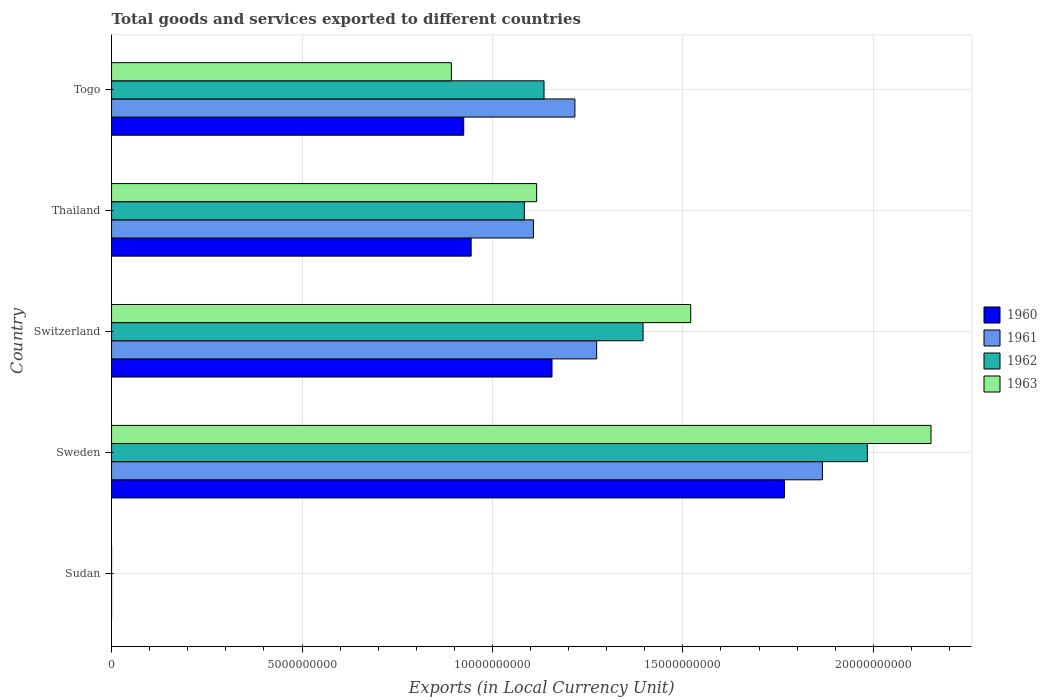Are the number of bars on each tick of the Y-axis equal?
Your response must be concise. Yes. How many bars are there on the 2nd tick from the bottom?
Provide a short and direct response. 4. What is the label of the 1st group of bars from the top?
Ensure brevity in your answer.  Togo. In how many cases, is the number of bars for a given country not equal to the number of legend labels?
Provide a succinct answer. 0. What is the Amount of goods and services exports in 1963 in Thailand?
Provide a short and direct response. 1.12e+1. Across all countries, what is the maximum Amount of goods and services exports in 1960?
Your response must be concise. 1.77e+1. Across all countries, what is the minimum Amount of goods and services exports in 1961?
Offer a terse response. 5.67e+04. In which country was the Amount of goods and services exports in 1960 minimum?
Your response must be concise. Sudan. What is the total Amount of goods and services exports in 1962 in the graph?
Keep it short and to the point. 5.60e+1. What is the difference between the Amount of goods and services exports in 1961 in Sweden and that in Thailand?
Your answer should be very brief. 7.59e+09. What is the difference between the Amount of goods and services exports in 1961 in Sudan and the Amount of goods and services exports in 1962 in Thailand?
Your response must be concise. -1.08e+1. What is the average Amount of goods and services exports in 1960 per country?
Make the answer very short. 9.58e+09. What is the difference between the Amount of goods and services exports in 1962 and Amount of goods and services exports in 1963 in Switzerland?
Keep it short and to the point. -1.25e+09. What is the ratio of the Amount of goods and services exports in 1960 in Sudan to that in Thailand?
Your answer should be compact. 6.0480881262578115e-6. Is the difference between the Amount of goods and services exports in 1962 in Switzerland and Togo greater than the difference between the Amount of goods and services exports in 1963 in Switzerland and Togo?
Provide a succinct answer. No. What is the difference between the highest and the second highest Amount of goods and services exports in 1963?
Your response must be concise. 6.31e+09. What is the difference between the highest and the lowest Amount of goods and services exports in 1962?
Keep it short and to the point. 1.98e+1. Is the sum of the Amount of goods and services exports in 1962 in Sweden and Togo greater than the maximum Amount of goods and services exports in 1961 across all countries?
Offer a very short reply. Yes. What does the 1st bar from the bottom in Sudan represents?
Make the answer very short. 1960. Is it the case that in every country, the sum of the Amount of goods and services exports in 1963 and Amount of goods and services exports in 1962 is greater than the Amount of goods and services exports in 1961?
Offer a very short reply. Yes. What is the difference between two consecutive major ticks on the X-axis?
Provide a succinct answer. 5.00e+09. Does the graph contain grids?
Provide a short and direct response. Yes. What is the title of the graph?
Offer a terse response. Total goods and services exported to different countries. Does "2001" appear as one of the legend labels in the graph?
Give a very brief answer. No. What is the label or title of the X-axis?
Provide a succinct answer. Exports (in Local Currency Unit). What is the label or title of the Y-axis?
Provide a short and direct response. Country. What is the Exports (in Local Currency Unit) in 1960 in Sudan?
Keep it short and to the point. 5.71e+04. What is the Exports (in Local Currency Unit) in 1961 in Sudan?
Provide a succinct answer. 5.67e+04. What is the Exports (in Local Currency Unit) in 1962 in Sudan?
Keep it short and to the point. 6.76e+04. What is the Exports (in Local Currency Unit) of 1963 in Sudan?
Ensure brevity in your answer.  7.86e+04. What is the Exports (in Local Currency Unit) of 1960 in Sweden?
Offer a terse response. 1.77e+1. What is the Exports (in Local Currency Unit) of 1961 in Sweden?
Provide a short and direct response. 1.87e+1. What is the Exports (in Local Currency Unit) of 1962 in Sweden?
Keep it short and to the point. 1.98e+1. What is the Exports (in Local Currency Unit) of 1963 in Sweden?
Make the answer very short. 2.15e+1. What is the Exports (in Local Currency Unit) in 1960 in Switzerland?
Your answer should be very brief. 1.16e+1. What is the Exports (in Local Currency Unit) in 1961 in Switzerland?
Your answer should be very brief. 1.27e+1. What is the Exports (in Local Currency Unit) of 1962 in Switzerland?
Offer a terse response. 1.40e+1. What is the Exports (in Local Currency Unit) in 1963 in Switzerland?
Make the answer very short. 1.52e+1. What is the Exports (in Local Currency Unit) of 1960 in Thailand?
Ensure brevity in your answer.  9.44e+09. What is the Exports (in Local Currency Unit) of 1961 in Thailand?
Keep it short and to the point. 1.11e+1. What is the Exports (in Local Currency Unit) in 1962 in Thailand?
Give a very brief answer. 1.08e+1. What is the Exports (in Local Currency Unit) in 1963 in Thailand?
Your answer should be very brief. 1.12e+1. What is the Exports (in Local Currency Unit) of 1960 in Togo?
Keep it short and to the point. 9.25e+09. What is the Exports (in Local Currency Unit) of 1961 in Togo?
Give a very brief answer. 1.22e+1. What is the Exports (in Local Currency Unit) in 1962 in Togo?
Keep it short and to the point. 1.14e+1. What is the Exports (in Local Currency Unit) in 1963 in Togo?
Give a very brief answer. 8.92e+09. Across all countries, what is the maximum Exports (in Local Currency Unit) of 1960?
Offer a very short reply. 1.77e+1. Across all countries, what is the maximum Exports (in Local Currency Unit) in 1961?
Make the answer very short. 1.87e+1. Across all countries, what is the maximum Exports (in Local Currency Unit) of 1962?
Ensure brevity in your answer.  1.98e+1. Across all countries, what is the maximum Exports (in Local Currency Unit) of 1963?
Offer a terse response. 2.15e+1. Across all countries, what is the minimum Exports (in Local Currency Unit) of 1960?
Ensure brevity in your answer.  5.71e+04. Across all countries, what is the minimum Exports (in Local Currency Unit) of 1961?
Your answer should be very brief. 5.67e+04. Across all countries, what is the minimum Exports (in Local Currency Unit) in 1962?
Your response must be concise. 6.76e+04. Across all countries, what is the minimum Exports (in Local Currency Unit) in 1963?
Ensure brevity in your answer.  7.86e+04. What is the total Exports (in Local Currency Unit) of 1960 in the graph?
Provide a short and direct response. 4.79e+1. What is the total Exports (in Local Currency Unit) of 1961 in the graph?
Provide a short and direct response. 5.46e+1. What is the total Exports (in Local Currency Unit) of 1962 in the graph?
Keep it short and to the point. 5.60e+1. What is the total Exports (in Local Currency Unit) of 1963 in the graph?
Make the answer very short. 5.68e+1. What is the difference between the Exports (in Local Currency Unit) in 1960 in Sudan and that in Sweden?
Your answer should be compact. -1.77e+1. What is the difference between the Exports (in Local Currency Unit) in 1961 in Sudan and that in Sweden?
Your answer should be very brief. -1.87e+1. What is the difference between the Exports (in Local Currency Unit) of 1962 in Sudan and that in Sweden?
Provide a short and direct response. -1.98e+1. What is the difference between the Exports (in Local Currency Unit) of 1963 in Sudan and that in Sweden?
Your answer should be compact. -2.15e+1. What is the difference between the Exports (in Local Currency Unit) in 1960 in Sudan and that in Switzerland?
Offer a very short reply. -1.16e+1. What is the difference between the Exports (in Local Currency Unit) of 1961 in Sudan and that in Switzerland?
Offer a terse response. -1.27e+1. What is the difference between the Exports (in Local Currency Unit) in 1962 in Sudan and that in Switzerland?
Offer a terse response. -1.40e+1. What is the difference between the Exports (in Local Currency Unit) in 1963 in Sudan and that in Switzerland?
Give a very brief answer. -1.52e+1. What is the difference between the Exports (in Local Currency Unit) in 1960 in Sudan and that in Thailand?
Keep it short and to the point. -9.44e+09. What is the difference between the Exports (in Local Currency Unit) in 1961 in Sudan and that in Thailand?
Offer a very short reply. -1.11e+1. What is the difference between the Exports (in Local Currency Unit) of 1962 in Sudan and that in Thailand?
Ensure brevity in your answer.  -1.08e+1. What is the difference between the Exports (in Local Currency Unit) of 1963 in Sudan and that in Thailand?
Offer a very short reply. -1.12e+1. What is the difference between the Exports (in Local Currency Unit) in 1960 in Sudan and that in Togo?
Offer a very short reply. -9.25e+09. What is the difference between the Exports (in Local Currency Unit) of 1961 in Sudan and that in Togo?
Give a very brief answer. -1.22e+1. What is the difference between the Exports (in Local Currency Unit) of 1962 in Sudan and that in Togo?
Offer a terse response. -1.14e+1. What is the difference between the Exports (in Local Currency Unit) of 1963 in Sudan and that in Togo?
Keep it short and to the point. -8.92e+09. What is the difference between the Exports (in Local Currency Unit) of 1960 in Sweden and that in Switzerland?
Make the answer very short. 6.10e+09. What is the difference between the Exports (in Local Currency Unit) in 1961 in Sweden and that in Switzerland?
Keep it short and to the point. 5.93e+09. What is the difference between the Exports (in Local Currency Unit) of 1962 in Sweden and that in Switzerland?
Provide a succinct answer. 5.89e+09. What is the difference between the Exports (in Local Currency Unit) in 1963 in Sweden and that in Switzerland?
Offer a terse response. 6.31e+09. What is the difference between the Exports (in Local Currency Unit) in 1960 in Sweden and that in Thailand?
Ensure brevity in your answer.  8.23e+09. What is the difference between the Exports (in Local Currency Unit) in 1961 in Sweden and that in Thailand?
Provide a succinct answer. 7.59e+09. What is the difference between the Exports (in Local Currency Unit) in 1962 in Sweden and that in Thailand?
Make the answer very short. 9.01e+09. What is the difference between the Exports (in Local Currency Unit) of 1963 in Sweden and that in Thailand?
Your answer should be very brief. 1.04e+1. What is the difference between the Exports (in Local Currency Unit) in 1960 in Sweden and that in Togo?
Provide a succinct answer. 8.42e+09. What is the difference between the Exports (in Local Currency Unit) of 1961 in Sweden and that in Togo?
Give a very brief answer. 6.50e+09. What is the difference between the Exports (in Local Currency Unit) of 1962 in Sweden and that in Togo?
Provide a short and direct response. 8.49e+09. What is the difference between the Exports (in Local Currency Unit) of 1963 in Sweden and that in Togo?
Offer a terse response. 1.26e+1. What is the difference between the Exports (in Local Currency Unit) of 1960 in Switzerland and that in Thailand?
Your response must be concise. 2.12e+09. What is the difference between the Exports (in Local Currency Unit) of 1961 in Switzerland and that in Thailand?
Provide a succinct answer. 1.66e+09. What is the difference between the Exports (in Local Currency Unit) in 1962 in Switzerland and that in Thailand?
Offer a very short reply. 3.12e+09. What is the difference between the Exports (in Local Currency Unit) of 1963 in Switzerland and that in Thailand?
Your answer should be very brief. 4.05e+09. What is the difference between the Exports (in Local Currency Unit) in 1960 in Switzerland and that in Togo?
Your response must be concise. 2.32e+09. What is the difference between the Exports (in Local Currency Unit) in 1961 in Switzerland and that in Togo?
Provide a succinct answer. 5.70e+08. What is the difference between the Exports (in Local Currency Unit) of 1962 in Switzerland and that in Togo?
Provide a short and direct response. 2.60e+09. What is the difference between the Exports (in Local Currency Unit) of 1963 in Switzerland and that in Togo?
Make the answer very short. 6.28e+09. What is the difference between the Exports (in Local Currency Unit) of 1960 in Thailand and that in Togo?
Provide a succinct answer. 1.95e+08. What is the difference between the Exports (in Local Currency Unit) in 1961 in Thailand and that in Togo?
Make the answer very short. -1.09e+09. What is the difference between the Exports (in Local Currency Unit) in 1962 in Thailand and that in Togo?
Offer a terse response. -5.17e+08. What is the difference between the Exports (in Local Currency Unit) of 1963 in Thailand and that in Togo?
Provide a succinct answer. 2.24e+09. What is the difference between the Exports (in Local Currency Unit) in 1960 in Sudan and the Exports (in Local Currency Unit) in 1961 in Sweden?
Ensure brevity in your answer.  -1.87e+1. What is the difference between the Exports (in Local Currency Unit) in 1960 in Sudan and the Exports (in Local Currency Unit) in 1962 in Sweden?
Offer a very short reply. -1.98e+1. What is the difference between the Exports (in Local Currency Unit) in 1960 in Sudan and the Exports (in Local Currency Unit) in 1963 in Sweden?
Give a very brief answer. -2.15e+1. What is the difference between the Exports (in Local Currency Unit) of 1961 in Sudan and the Exports (in Local Currency Unit) of 1962 in Sweden?
Your response must be concise. -1.98e+1. What is the difference between the Exports (in Local Currency Unit) of 1961 in Sudan and the Exports (in Local Currency Unit) of 1963 in Sweden?
Provide a succinct answer. -2.15e+1. What is the difference between the Exports (in Local Currency Unit) in 1962 in Sudan and the Exports (in Local Currency Unit) in 1963 in Sweden?
Your answer should be very brief. -2.15e+1. What is the difference between the Exports (in Local Currency Unit) of 1960 in Sudan and the Exports (in Local Currency Unit) of 1961 in Switzerland?
Provide a short and direct response. -1.27e+1. What is the difference between the Exports (in Local Currency Unit) in 1960 in Sudan and the Exports (in Local Currency Unit) in 1962 in Switzerland?
Your answer should be very brief. -1.40e+1. What is the difference between the Exports (in Local Currency Unit) in 1960 in Sudan and the Exports (in Local Currency Unit) in 1963 in Switzerland?
Provide a succinct answer. -1.52e+1. What is the difference between the Exports (in Local Currency Unit) of 1961 in Sudan and the Exports (in Local Currency Unit) of 1962 in Switzerland?
Provide a succinct answer. -1.40e+1. What is the difference between the Exports (in Local Currency Unit) of 1961 in Sudan and the Exports (in Local Currency Unit) of 1963 in Switzerland?
Your answer should be compact. -1.52e+1. What is the difference between the Exports (in Local Currency Unit) in 1962 in Sudan and the Exports (in Local Currency Unit) in 1963 in Switzerland?
Keep it short and to the point. -1.52e+1. What is the difference between the Exports (in Local Currency Unit) of 1960 in Sudan and the Exports (in Local Currency Unit) of 1961 in Thailand?
Provide a short and direct response. -1.11e+1. What is the difference between the Exports (in Local Currency Unit) in 1960 in Sudan and the Exports (in Local Currency Unit) in 1962 in Thailand?
Your answer should be very brief. -1.08e+1. What is the difference between the Exports (in Local Currency Unit) of 1960 in Sudan and the Exports (in Local Currency Unit) of 1963 in Thailand?
Offer a very short reply. -1.12e+1. What is the difference between the Exports (in Local Currency Unit) in 1961 in Sudan and the Exports (in Local Currency Unit) in 1962 in Thailand?
Make the answer very short. -1.08e+1. What is the difference between the Exports (in Local Currency Unit) in 1961 in Sudan and the Exports (in Local Currency Unit) in 1963 in Thailand?
Your response must be concise. -1.12e+1. What is the difference between the Exports (in Local Currency Unit) in 1962 in Sudan and the Exports (in Local Currency Unit) in 1963 in Thailand?
Provide a succinct answer. -1.12e+1. What is the difference between the Exports (in Local Currency Unit) of 1960 in Sudan and the Exports (in Local Currency Unit) of 1961 in Togo?
Provide a succinct answer. -1.22e+1. What is the difference between the Exports (in Local Currency Unit) of 1960 in Sudan and the Exports (in Local Currency Unit) of 1962 in Togo?
Provide a succinct answer. -1.14e+1. What is the difference between the Exports (in Local Currency Unit) of 1960 in Sudan and the Exports (in Local Currency Unit) of 1963 in Togo?
Your response must be concise. -8.92e+09. What is the difference between the Exports (in Local Currency Unit) in 1961 in Sudan and the Exports (in Local Currency Unit) in 1962 in Togo?
Your answer should be very brief. -1.14e+1. What is the difference between the Exports (in Local Currency Unit) in 1961 in Sudan and the Exports (in Local Currency Unit) in 1963 in Togo?
Your response must be concise. -8.92e+09. What is the difference between the Exports (in Local Currency Unit) in 1962 in Sudan and the Exports (in Local Currency Unit) in 1963 in Togo?
Offer a terse response. -8.92e+09. What is the difference between the Exports (in Local Currency Unit) in 1960 in Sweden and the Exports (in Local Currency Unit) in 1961 in Switzerland?
Offer a terse response. 4.93e+09. What is the difference between the Exports (in Local Currency Unit) of 1960 in Sweden and the Exports (in Local Currency Unit) of 1962 in Switzerland?
Your response must be concise. 3.71e+09. What is the difference between the Exports (in Local Currency Unit) in 1960 in Sweden and the Exports (in Local Currency Unit) in 1963 in Switzerland?
Make the answer very short. 2.46e+09. What is the difference between the Exports (in Local Currency Unit) in 1961 in Sweden and the Exports (in Local Currency Unit) in 1962 in Switzerland?
Your answer should be very brief. 4.71e+09. What is the difference between the Exports (in Local Currency Unit) in 1961 in Sweden and the Exports (in Local Currency Unit) in 1963 in Switzerland?
Ensure brevity in your answer.  3.46e+09. What is the difference between the Exports (in Local Currency Unit) of 1962 in Sweden and the Exports (in Local Currency Unit) of 1963 in Switzerland?
Keep it short and to the point. 4.64e+09. What is the difference between the Exports (in Local Currency Unit) in 1960 in Sweden and the Exports (in Local Currency Unit) in 1961 in Thailand?
Make the answer very short. 6.59e+09. What is the difference between the Exports (in Local Currency Unit) of 1960 in Sweden and the Exports (in Local Currency Unit) of 1962 in Thailand?
Give a very brief answer. 6.83e+09. What is the difference between the Exports (in Local Currency Unit) of 1960 in Sweden and the Exports (in Local Currency Unit) of 1963 in Thailand?
Provide a short and direct response. 6.51e+09. What is the difference between the Exports (in Local Currency Unit) in 1961 in Sweden and the Exports (in Local Currency Unit) in 1962 in Thailand?
Make the answer very short. 7.83e+09. What is the difference between the Exports (in Local Currency Unit) of 1961 in Sweden and the Exports (in Local Currency Unit) of 1963 in Thailand?
Make the answer very short. 7.50e+09. What is the difference between the Exports (in Local Currency Unit) in 1962 in Sweden and the Exports (in Local Currency Unit) in 1963 in Thailand?
Ensure brevity in your answer.  8.68e+09. What is the difference between the Exports (in Local Currency Unit) in 1960 in Sweden and the Exports (in Local Currency Unit) in 1961 in Togo?
Make the answer very short. 5.50e+09. What is the difference between the Exports (in Local Currency Unit) in 1960 in Sweden and the Exports (in Local Currency Unit) in 1962 in Togo?
Your response must be concise. 6.31e+09. What is the difference between the Exports (in Local Currency Unit) in 1960 in Sweden and the Exports (in Local Currency Unit) in 1963 in Togo?
Give a very brief answer. 8.75e+09. What is the difference between the Exports (in Local Currency Unit) of 1961 in Sweden and the Exports (in Local Currency Unit) of 1962 in Togo?
Your answer should be compact. 7.31e+09. What is the difference between the Exports (in Local Currency Unit) in 1961 in Sweden and the Exports (in Local Currency Unit) in 1963 in Togo?
Make the answer very short. 9.74e+09. What is the difference between the Exports (in Local Currency Unit) of 1962 in Sweden and the Exports (in Local Currency Unit) of 1963 in Togo?
Provide a succinct answer. 1.09e+1. What is the difference between the Exports (in Local Currency Unit) of 1960 in Switzerland and the Exports (in Local Currency Unit) of 1961 in Thailand?
Provide a short and direct response. 4.88e+08. What is the difference between the Exports (in Local Currency Unit) of 1960 in Switzerland and the Exports (in Local Currency Unit) of 1962 in Thailand?
Your answer should be very brief. 7.26e+08. What is the difference between the Exports (in Local Currency Unit) in 1960 in Switzerland and the Exports (in Local Currency Unit) in 1963 in Thailand?
Your answer should be compact. 4.03e+08. What is the difference between the Exports (in Local Currency Unit) in 1961 in Switzerland and the Exports (in Local Currency Unit) in 1962 in Thailand?
Your answer should be very brief. 1.90e+09. What is the difference between the Exports (in Local Currency Unit) in 1961 in Switzerland and the Exports (in Local Currency Unit) in 1963 in Thailand?
Offer a terse response. 1.58e+09. What is the difference between the Exports (in Local Currency Unit) of 1962 in Switzerland and the Exports (in Local Currency Unit) of 1963 in Thailand?
Provide a succinct answer. 2.79e+09. What is the difference between the Exports (in Local Currency Unit) in 1960 in Switzerland and the Exports (in Local Currency Unit) in 1961 in Togo?
Provide a succinct answer. -6.01e+08. What is the difference between the Exports (in Local Currency Unit) of 1960 in Switzerland and the Exports (in Local Currency Unit) of 1962 in Togo?
Ensure brevity in your answer.  2.10e+08. What is the difference between the Exports (in Local Currency Unit) of 1960 in Switzerland and the Exports (in Local Currency Unit) of 1963 in Togo?
Your answer should be very brief. 2.64e+09. What is the difference between the Exports (in Local Currency Unit) of 1961 in Switzerland and the Exports (in Local Currency Unit) of 1962 in Togo?
Offer a terse response. 1.38e+09. What is the difference between the Exports (in Local Currency Unit) of 1961 in Switzerland and the Exports (in Local Currency Unit) of 1963 in Togo?
Ensure brevity in your answer.  3.81e+09. What is the difference between the Exports (in Local Currency Unit) of 1962 in Switzerland and the Exports (in Local Currency Unit) of 1963 in Togo?
Keep it short and to the point. 5.03e+09. What is the difference between the Exports (in Local Currency Unit) of 1960 in Thailand and the Exports (in Local Currency Unit) of 1961 in Togo?
Your answer should be compact. -2.72e+09. What is the difference between the Exports (in Local Currency Unit) in 1960 in Thailand and the Exports (in Local Currency Unit) in 1962 in Togo?
Ensure brevity in your answer.  -1.91e+09. What is the difference between the Exports (in Local Currency Unit) of 1960 in Thailand and the Exports (in Local Currency Unit) of 1963 in Togo?
Offer a terse response. 5.19e+08. What is the difference between the Exports (in Local Currency Unit) in 1961 in Thailand and the Exports (in Local Currency Unit) in 1962 in Togo?
Make the answer very short. -2.79e+08. What is the difference between the Exports (in Local Currency Unit) in 1961 in Thailand and the Exports (in Local Currency Unit) in 1963 in Togo?
Provide a succinct answer. 2.15e+09. What is the difference between the Exports (in Local Currency Unit) of 1962 in Thailand and the Exports (in Local Currency Unit) of 1963 in Togo?
Offer a very short reply. 1.92e+09. What is the average Exports (in Local Currency Unit) of 1960 per country?
Offer a very short reply. 9.58e+09. What is the average Exports (in Local Currency Unit) in 1961 per country?
Your answer should be very brief. 1.09e+1. What is the average Exports (in Local Currency Unit) of 1962 per country?
Your answer should be compact. 1.12e+1. What is the average Exports (in Local Currency Unit) in 1963 per country?
Give a very brief answer. 1.14e+1. What is the difference between the Exports (in Local Currency Unit) of 1960 and Exports (in Local Currency Unit) of 1961 in Sudan?
Your response must be concise. 400. What is the difference between the Exports (in Local Currency Unit) in 1960 and Exports (in Local Currency Unit) in 1962 in Sudan?
Make the answer very short. -1.05e+04. What is the difference between the Exports (in Local Currency Unit) in 1960 and Exports (in Local Currency Unit) in 1963 in Sudan?
Provide a succinct answer. -2.15e+04. What is the difference between the Exports (in Local Currency Unit) in 1961 and Exports (in Local Currency Unit) in 1962 in Sudan?
Offer a very short reply. -1.09e+04. What is the difference between the Exports (in Local Currency Unit) in 1961 and Exports (in Local Currency Unit) in 1963 in Sudan?
Give a very brief answer. -2.19e+04. What is the difference between the Exports (in Local Currency Unit) of 1962 and Exports (in Local Currency Unit) of 1963 in Sudan?
Ensure brevity in your answer.  -1.10e+04. What is the difference between the Exports (in Local Currency Unit) in 1960 and Exports (in Local Currency Unit) in 1961 in Sweden?
Offer a terse response. -9.97e+08. What is the difference between the Exports (in Local Currency Unit) of 1960 and Exports (in Local Currency Unit) of 1962 in Sweden?
Your answer should be compact. -2.18e+09. What is the difference between the Exports (in Local Currency Unit) in 1960 and Exports (in Local Currency Unit) in 1963 in Sweden?
Provide a succinct answer. -3.85e+09. What is the difference between the Exports (in Local Currency Unit) of 1961 and Exports (in Local Currency Unit) of 1962 in Sweden?
Your response must be concise. -1.18e+09. What is the difference between the Exports (in Local Currency Unit) in 1961 and Exports (in Local Currency Unit) in 1963 in Sweden?
Your answer should be very brief. -2.85e+09. What is the difference between the Exports (in Local Currency Unit) in 1962 and Exports (in Local Currency Unit) in 1963 in Sweden?
Ensure brevity in your answer.  -1.67e+09. What is the difference between the Exports (in Local Currency Unit) of 1960 and Exports (in Local Currency Unit) of 1961 in Switzerland?
Give a very brief answer. -1.17e+09. What is the difference between the Exports (in Local Currency Unit) in 1960 and Exports (in Local Currency Unit) in 1962 in Switzerland?
Offer a very short reply. -2.39e+09. What is the difference between the Exports (in Local Currency Unit) in 1960 and Exports (in Local Currency Unit) in 1963 in Switzerland?
Offer a terse response. -3.64e+09. What is the difference between the Exports (in Local Currency Unit) of 1961 and Exports (in Local Currency Unit) of 1962 in Switzerland?
Your answer should be compact. -1.22e+09. What is the difference between the Exports (in Local Currency Unit) of 1961 and Exports (in Local Currency Unit) of 1963 in Switzerland?
Your answer should be very brief. -2.47e+09. What is the difference between the Exports (in Local Currency Unit) in 1962 and Exports (in Local Currency Unit) in 1963 in Switzerland?
Your answer should be very brief. -1.25e+09. What is the difference between the Exports (in Local Currency Unit) of 1960 and Exports (in Local Currency Unit) of 1961 in Thailand?
Your response must be concise. -1.64e+09. What is the difference between the Exports (in Local Currency Unit) of 1960 and Exports (in Local Currency Unit) of 1962 in Thailand?
Offer a very short reply. -1.40e+09. What is the difference between the Exports (in Local Currency Unit) in 1960 and Exports (in Local Currency Unit) in 1963 in Thailand?
Give a very brief answer. -1.72e+09. What is the difference between the Exports (in Local Currency Unit) of 1961 and Exports (in Local Currency Unit) of 1962 in Thailand?
Offer a terse response. 2.38e+08. What is the difference between the Exports (in Local Currency Unit) in 1961 and Exports (in Local Currency Unit) in 1963 in Thailand?
Provide a succinct answer. -8.50e+07. What is the difference between the Exports (in Local Currency Unit) in 1962 and Exports (in Local Currency Unit) in 1963 in Thailand?
Your response must be concise. -3.23e+08. What is the difference between the Exports (in Local Currency Unit) in 1960 and Exports (in Local Currency Unit) in 1961 in Togo?
Your response must be concise. -2.92e+09. What is the difference between the Exports (in Local Currency Unit) of 1960 and Exports (in Local Currency Unit) of 1962 in Togo?
Ensure brevity in your answer.  -2.11e+09. What is the difference between the Exports (in Local Currency Unit) in 1960 and Exports (in Local Currency Unit) in 1963 in Togo?
Give a very brief answer. 3.24e+08. What is the difference between the Exports (in Local Currency Unit) of 1961 and Exports (in Local Currency Unit) of 1962 in Togo?
Keep it short and to the point. 8.11e+08. What is the difference between the Exports (in Local Currency Unit) of 1961 and Exports (in Local Currency Unit) of 1963 in Togo?
Keep it short and to the point. 3.24e+09. What is the difference between the Exports (in Local Currency Unit) in 1962 and Exports (in Local Currency Unit) in 1963 in Togo?
Offer a terse response. 2.43e+09. What is the ratio of the Exports (in Local Currency Unit) in 1960 in Sudan to that in Sweden?
Offer a very short reply. 0. What is the ratio of the Exports (in Local Currency Unit) of 1961 in Sudan to that in Sweden?
Your answer should be compact. 0. What is the ratio of the Exports (in Local Currency Unit) in 1962 in Sudan to that in Sweden?
Your response must be concise. 0. What is the ratio of the Exports (in Local Currency Unit) of 1960 in Sudan to that in Switzerland?
Make the answer very short. 0. What is the ratio of the Exports (in Local Currency Unit) of 1963 in Sudan to that in Switzerland?
Ensure brevity in your answer.  0. What is the ratio of the Exports (in Local Currency Unit) in 1960 in Sudan to that in Thailand?
Offer a terse response. 0. What is the ratio of the Exports (in Local Currency Unit) in 1961 in Sudan to that in Thailand?
Ensure brevity in your answer.  0. What is the ratio of the Exports (in Local Currency Unit) of 1960 in Sudan to that in Togo?
Offer a terse response. 0. What is the ratio of the Exports (in Local Currency Unit) in 1961 in Sudan to that in Togo?
Offer a very short reply. 0. What is the ratio of the Exports (in Local Currency Unit) of 1962 in Sudan to that in Togo?
Offer a terse response. 0. What is the ratio of the Exports (in Local Currency Unit) in 1960 in Sweden to that in Switzerland?
Keep it short and to the point. 1.53. What is the ratio of the Exports (in Local Currency Unit) in 1961 in Sweden to that in Switzerland?
Your response must be concise. 1.47. What is the ratio of the Exports (in Local Currency Unit) in 1962 in Sweden to that in Switzerland?
Make the answer very short. 1.42. What is the ratio of the Exports (in Local Currency Unit) of 1963 in Sweden to that in Switzerland?
Your response must be concise. 1.41. What is the ratio of the Exports (in Local Currency Unit) of 1960 in Sweden to that in Thailand?
Ensure brevity in your answer.  1.87. What is the ratio of the Exports (in Local Currency Unit) of 1961 in Sweden to that in Thailand?
Make the answer very short. 1.69. What is the ratio of the Exports (in Local Currency Unit) in 1962 in Sweden to that in Thailand?
Give a very brief answer. 1.83. What is the ratio of the Exports (in Local Currency Unit) in 1963 in Sweden to that in Thailand?
Keep it short and to the point. 1.93. What is the ratio of the Exports (in Local Currency Unit) of 1960 in Sweden to that in Togo?
Provide a short and direct response. 1.91. What is the ratio of the Exports (in Local Currency Unit) of 1961 in Sweden to that in Togo?
Your answer should be very brief. 1.53. What is the ratio of the Exports (in Local Currency Unit) of 1962 in Sweden to that in Togo?
Provide a short and direct response. 1.75. What is the ratio of the Exports (in Local Currency Unit) in 1963 in Sweden to that in Togo?
Provide a succinct answer. 2.41. What is the ratio of the Exports (in Local Currency Unit) in 1960 in Switzerland to that in Thailand?
Your response must be concise. 1.22. What is the ratio of the Exports (in Local Currency Unit) of 1961 in Switzerland to that in Thailand?
Provide a succinct answer. 1.15. What is the ratio of the Exports (in Local Currency Unit) of 1962 in Switzerland to that in Thailand?
Provide a short and direct response. 1.29. What is the ratio of the Exports (in Local Currency Unit) of 1963 in Switzerland to that in Thailand?
Provide a succinct answer. 1.36. What is the ratio of the Exports (in Local Currency Unit) in 1960 in Switzerland to that in Togo?
Your response must be concise. 1.25. What is the ratio of the Exports (in Local Currency Unit) in 1961 in Switzerland to that in Togo?
Your answer should be compact. 1.05. What is the ratio of the Exports (in Local Currency Unit) of 1962 in Switzerland to that in Togo?
Give a very brief answer. 1.23. What is the ratio of the Exports (in Local Currency Unit) in 1963 in Switzerland to that in Togo?
Ensure brevity in your answer.  1.7. What is the ratio of the Exports (in Local Currency Unit) of 1960 in Thailand to that in Togo?
Keep it short and to the point. 1.02. What is the ratio of the Exports (in Local Currency Unit) of 1961 in Thailand to that in Togo?
Ensure brevity in your answer.  0.91. What is the ratio of the Exports (in Local Currency Unit) of 1962 in Thailand to that in Togo?
Keep it short and to the point. 0.95. What is the ratio of the Exports (in Local Currency Unit) in 1963 in Thailand to that in Togo?
Your answer should be very brief. 1.25. What is the difference between the highest and the second highest Exports (in Local Currency Unit) in 1960?
Your response must be concise. 6.10e+09. What is the difference between the highest and the second highest Exports (in Local Currency Unit) in 1961?
Your answer should be very brief. 5.93e+09. What is the difference between the highest and the second highest Exports (in Local Currency Unit) of 1962?
Your answer should be very brief. 5.89e+09. What is the difference between the highest and the second highest Exports (in Local Currency Unit) in 1963?
Your answer should be very brief. 6.31e+09. What is the difference between the highest and the lowest Exports (in Local Currency Unit) of 1960?
Make the answer very short. 1.77e+1. What is the difference between the highest and the lowest Exports (in Local Currency Unit) of 1961?
Ensure brevity in your answer.  1.87e+1. What is the difference between the highest and the lowest Exports (in Local Currency Unit) of 1962?
Keep it short and to the point. 1.98e+1. What is the difference between the highest and the lowest Exports (in Local Currency Unit) of 1963?
Provide a short and direct response. 2.15e+1. 